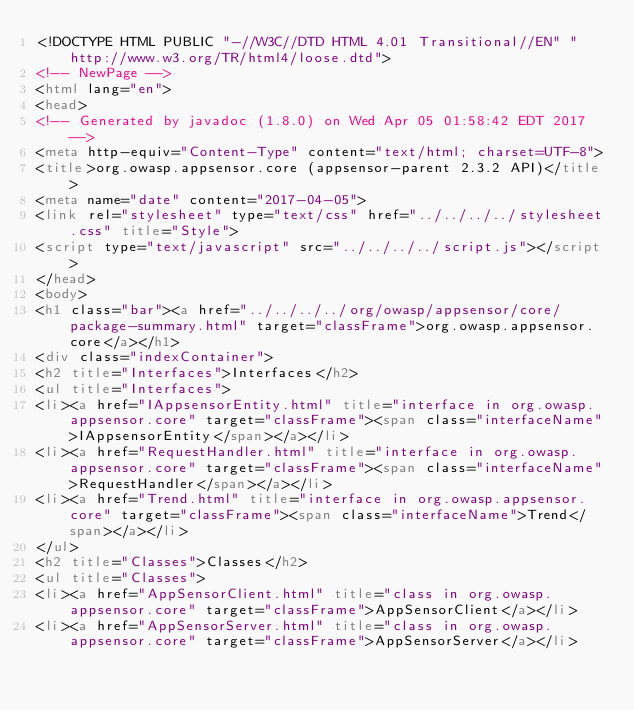<code> <loc_0><loc_0><loc_500><loc_500><_HTML_><!DOCTYPE HTML PUBLIC "-//W3C//DTD HTML 4.01 Transitional//EN" "http://www.w3.org/TR/html4/loose.dtd">
<!-- NewPage -->
<html lang="en">
<head>
<!-- Generated by javadoc (1.8.0) on Wed Apr 05 01:58:42 EDT 2017 -->
<meta http-equiv="Content-Type" content="text/html; charset=UTF-8">
<title>org.owasp.appsensor.core (appsensor-parent 2.3.2 API)</title>
<meta name="date" content="2017-04-05">
<link rel="stylesheet" type="text/css" href="../../../../stylesheet.css" title="Style">
<script type="text/javascript" src="../../../../script.js"></script>
</head>
<body>
<h1 class="bar"><a href="../../../../org/owasp/appsensor/core/package-summary.html" target="classFrame">org.owasp.appsensor.core</a></h1>
<div class="indexContainer">
<h2 title="Interfaces">Interfaces</h2>
<ul title="Interfaces">
<li><a href="IAppsensorEntity.html" title="interface in org.owasp.appsensor.core" target="classFrame"><span class="interfaceName">IAppsensorEntity</span></a></li>
<li><a href="RequestHandler.html" title="interface in org.owasp.appsensor.core" target="classFrame"><span class="interfaceName">RequestHandler</span></a></li>
<li><a href="Trend.html" title="interface in org.owasp.appsensor.core" target="classFrame"><span class="interfaceName">Trend</span></a></li>
</ul>
<h2 title="Classes">Classes</h2>
<ul title="Classes">
<li><a href="AppSensorClient.html" title="class in org.owasp.appsensor.core" target="classFrame">AppSensorClient</a></li>
<li><a href="AppSensorServer.html" title="class in org.owasp.appsensor.core" target="classFrame">AppSensorServer</a></li></code> 